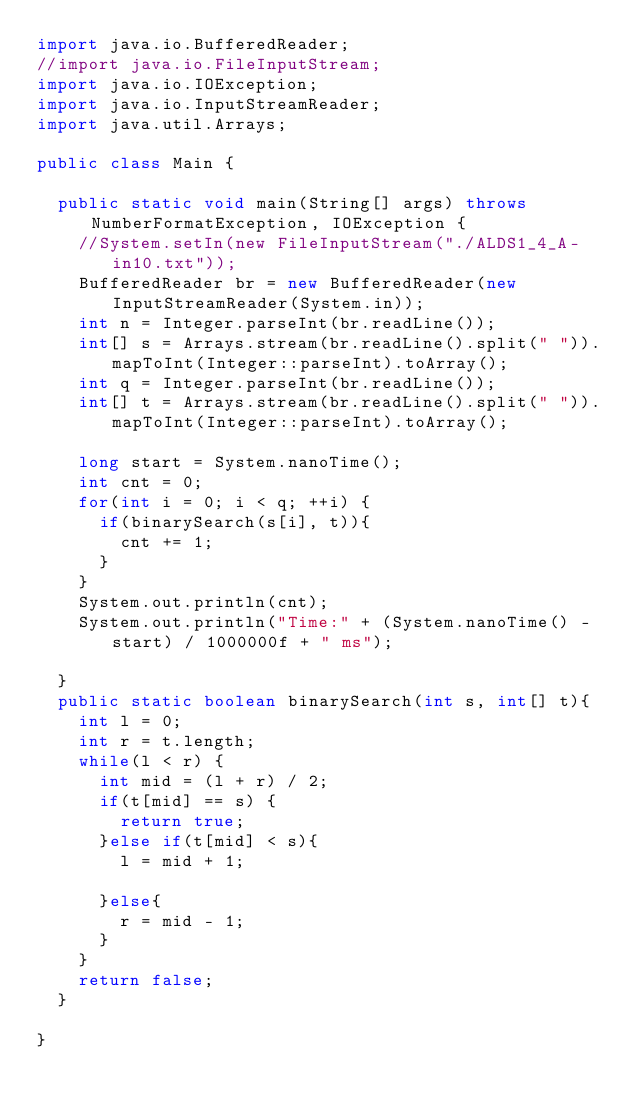<code> <loc_0><loc_0><loc_500><loc_500><_Java_>import java.io.BufferedReader;
//import java.io.FileInputStream;
import java.io.IOException;
import java.io.InputStreamReader;
import java.util.Arrays;

public class Main {

	public static void main(String[] args) throws NumberFormatException, IOException {
		//System.setIn(new FileInputStream("./ALDS1_4_A-in10.txt"));
		BufferedReader br = new BufferedReader(new InputStreamReader(System.in));
		int n = Integer.parseInt(br.readLine());
		int[] s = Arrays.stream(br.readLine().split(" ")).mapToInt(Integer::parseInt).toArray();
		int q = Integer.parseInt(br.readLine());
		int[] t = Arrays.stream(br.readLine().split(" ")).mapToInt(Integer::parseInt).toArray();
		
		long start = System.nanoTime();
		int cnt = 0;
		for(int i = 0; i < q; ++i) {
			if(binarySearch(s[i], t)){
				cnt += 1;
			}
		}
		System.out.println(cnt);
		System.out.println("Time:" + (System.nanoTime() - start) / 1000000f + " ms");

	}
	public static boolean binarySearch(int s, int[] t){
		int l = 0;
		int r = t.length;
		while(l < r) {
			int mid = (l + r) / 2;
			if(t[mid] == s) {
				return true;
			}else if(t[mid] < s){
				l = mid + 1;
			
			}else{
				r = mid - 1;
			}
		}
		return false;
	}

}</code> 